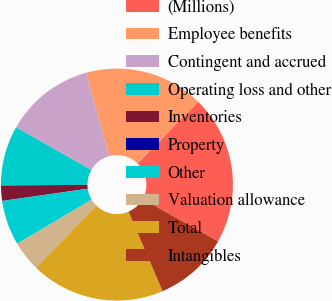Convert chart. <chart><loc_0><loc_0><loc_500><loc_500><pie_chart><fcel>(Millions)<fcel>Employee benefits<fcel>Contingent and accrued<fcel>Operating loss and other<fcel>Inventories<fcel>Property<fcel>Other<fcel>Valuation allowance<fcel>Total<fcel>Intangibles<nl><fcel>20.8%<fcel>16.65%<fcel>12.49%<fcel>8.34%<fcel>2.11%<fcel>0.03%<fcel>6.26%<fcel>4.18%<fcel>18.72%<fcel>10.42%<nl></chart> 